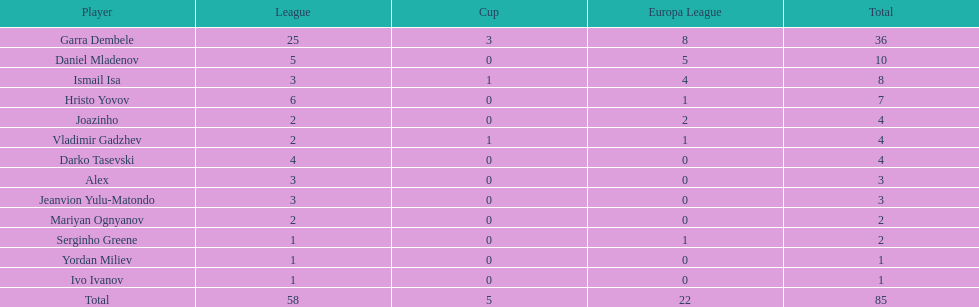Who are the individuals possessing at least 4 in the europa league? Garra Dembele, Daniel Mladenov, Ismail Isa. 